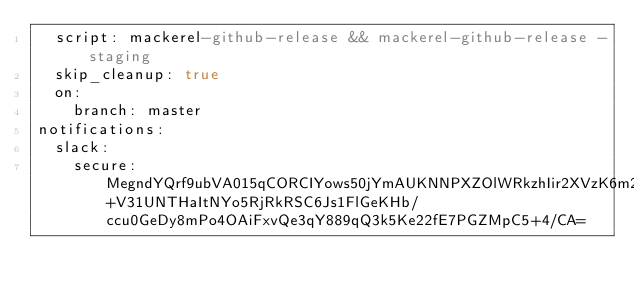<code> <loc_0><loc_0><loc_500><loc_500><_YAML_>  script: mackerel-github-release && mackerel-github-release -staging
  skip_cleanup: true
  on:
    branch: master
notifications:
  slack:
    secure: MegndYQrf9ubVA015qCORCIYows50jYmAUKNNPXZOlWRkzhIir2XVzK6m2vgZPxKmQpwcg0n1tAddmxw2lHwTC+V31UNTHaItNYo5RjRkRSC6Js1FlGeKHb/ccu0GeDy8mPo4OAiFxvQe3qY889qQ3k5Ke22fE7PGZMpC5+4/CA=
</code> 